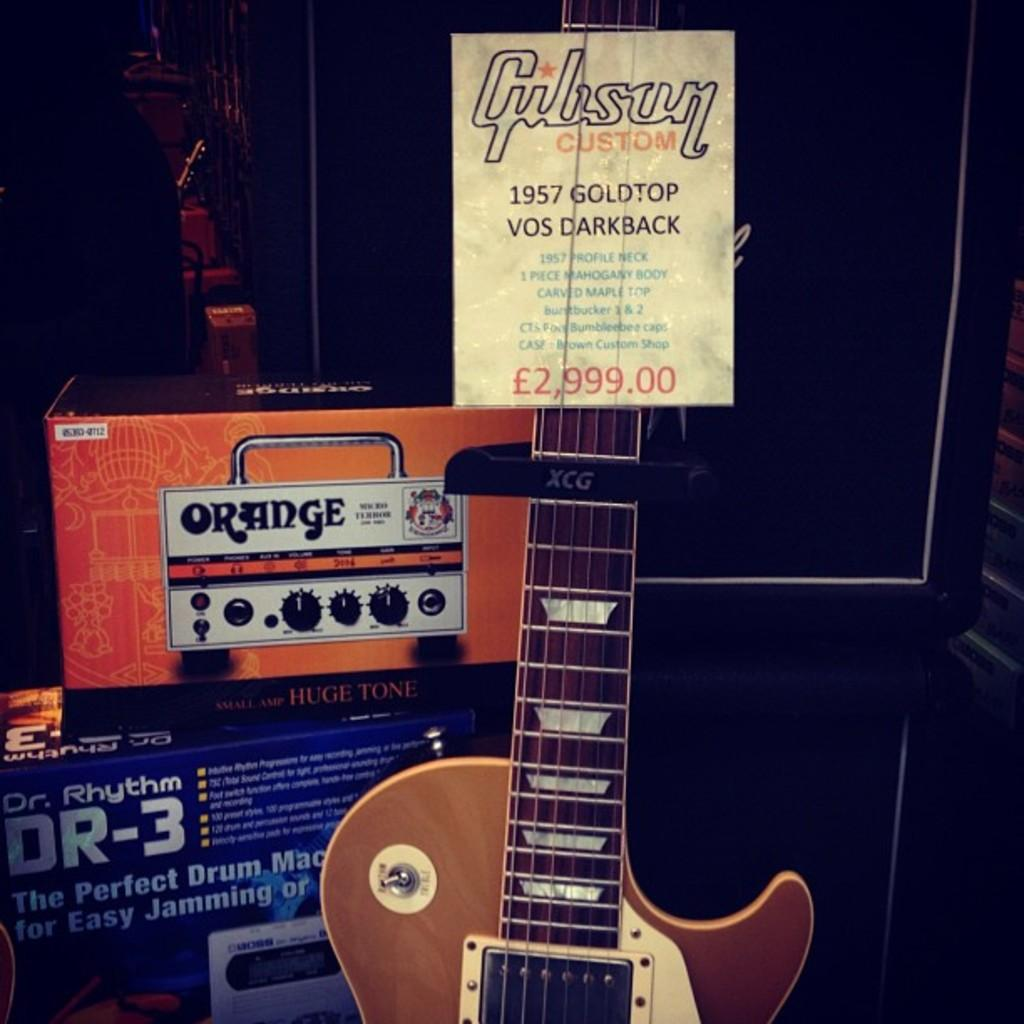What is the main object in the center of the image? There is a guitar in the center of the image. What can be seen in the background of the image? There are boxes and a poster in the background of the image. What type of soup is being served in the image? There is no soup present in the image; it features a guitar and background objects. 